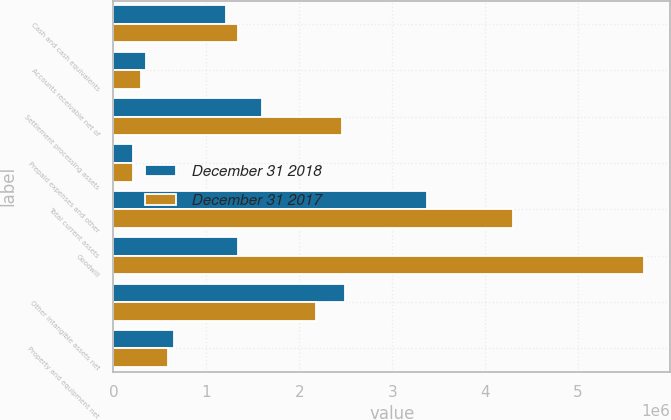<chart> <loc_0><loc_0><loc_500><loc_500><stacked_bar_chart><ecel><fcel>Cash and cash equivalents<fcel>Accounts receivable net of<fcel>Settlement processing assets<fcel>Prepaid expenses and other<fcel>Total current assets<fcel>Goodwill<fcel>Other intangible assets net<fcel>Property and equipment net<nl><fcel>December 31 2018<fcel>1.21088e+06<fcel>348400<fcel>1.60022e+06<fcel>216708<fcel>3.37621e+06<fcel>1.33586e+06<fcel>2.48862e+06<fcel>653542<nl><fcel>December 31 2017<fcel>1.33586e+06<fcel>301887<fcel>2.45929e+06<fcel>206545<fcel>4.30358e+06<fcel>5.70399e+06<fcel>2.18171e+06<fcel>588348<nl></chart> 